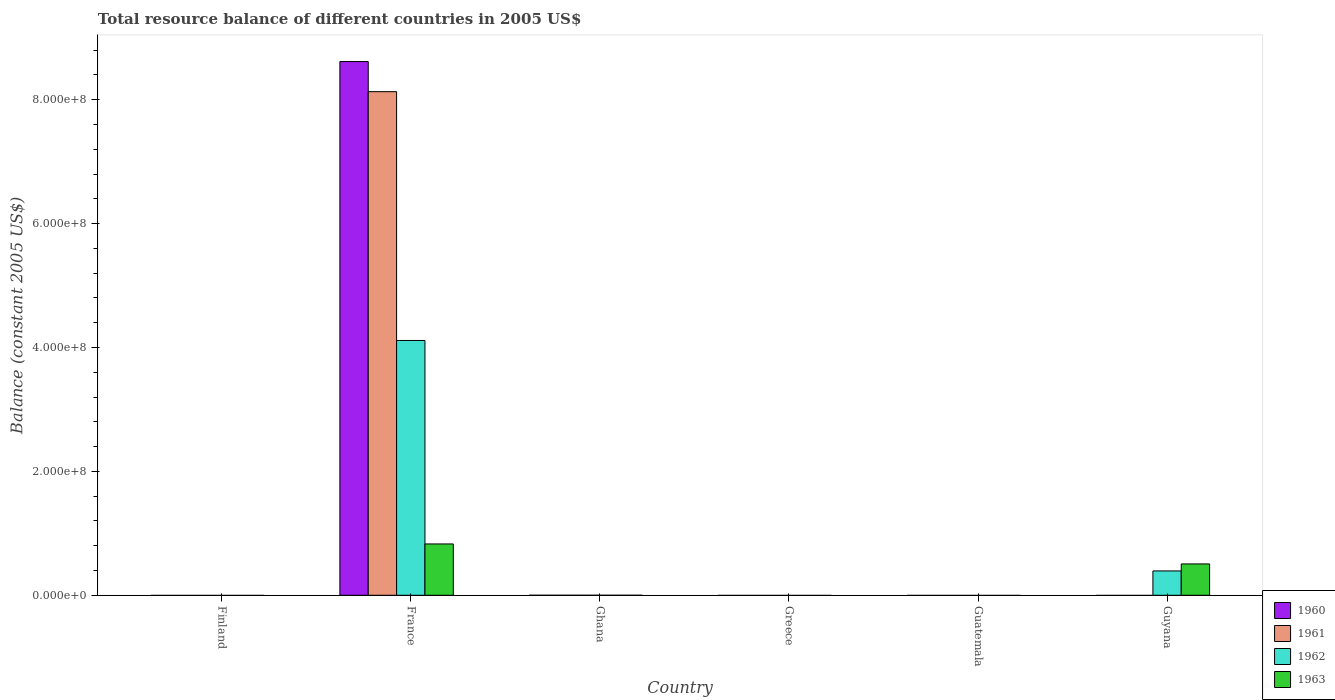How many bars are there on the 4th tick from the left?
Keep it short and to the point. 0. In how many cases, is the number of bars for a given country not equal to the number of legend labels?
Your answer should be very brief. 5. What is the total resource balance in 1961 in Guatemala?
Your answer should be very brief. 0. Across all countries, what is the maximum total resource balance in 1960?
Give a very brief answer. 8.62e+08. In which country was the total resource balance in 1963 maximum?
Give a very brief answer. France. What is the total total resource balance in 1960 in the graph?
Make the answer very short. 8.62e+08. What is the difference between the total resource balance in 1963 in France and the total resource balance in 1961 in Finland?
Offer a terse response. 8.29e+07. What is the average total resource balance in 1960 per country?
Make the answer very short. 1.44e+08. What is the difference between the total resource balance of/in 1963 and total resource balance of/in 1962 in France?
Give a very brief answer. -3.28e+08. What is the difference between the highest and the lowest total resource balance in 1963?
Provide a short and direct response. 8.29e+07. Is it the case that in every country, the sum of the total resource balance in 1960 and total resource balance in 1962 is greater than the sum of total resource balance in 1963 and total resource balance in 1961?
Provide a short and direct response. No. Is it the case that in every country, the sum of the total resource balance in 1963 and total resource balance in 1962 is greater than the total resource balance in 1960?
Ensure brevity in your answer.  No. How many bars are there?
Ensure brevity in your answer.  6. Are all the bars in the graph horizontal?
Provide a succinct answer. No. How many countries are there in the graph?
Your answer should be compact. 6. What is the difference between two consecutive major ticks on the Y-axis?
Your answer should be compact. 2.00e+08. Are the values on the major ticks of Y-axis written in scientific E-notation?
Make the answer very short. Yes. Does the graph contain any zero values?
Make the answer very short. Yes. How are the legend labels stacked?
Make the answer very short. Vertical. What is the title of the graph?
Keep it short and to the point. Total resource balance of different countries in 2005 US$. Does "2010" appear as one of the legend labels in the graph?
Offer a terse response. No. What is the label or title of the Y-axis?
Offer a very short reply. Balance (constant 2005 US$). What is the Balance (constant 2005 US$) of 1960 in Finland?
Make the answer very short. 0. What is the Balance (constant 2005 US$) in 1963 in Finland?
Your answer should be very brief. 0. What is the Balance (constant 2005 US$) of 1960 in France?
Your answer should be very brief. 8.62e+08. What is the Balance (constant 2005 US$) of 1961 in France?
Keep it short and to the point. 8.13e+08. What is the Balance (constant 2005 US$) of 1962 in France?
Offer a very short reply. 4.11e+08. What is the Balance (constant 2005 US$) of 1963 in France?
Offer a very short reply. 8.29e+07. What is the Balance (constant 2005 US$) in 1960 in Ghana?
Keep it short and to the point. 0. What is the Balance (constant 2005 US$) in 1961 in Ghana?
Provide a short and direct response. 0. What is the Balance (constant 2005 US$) of 1962 in Ghana?
Keep it short and to the point. 0. What is the Balance (constant 2005 US$) in 1960 in Greece?
Provide a short and direct response. 0. What is the Balance (constant 2005 US$) of 1961 in Greece?
Make the answer very short. 0. What is the Balance (constant 2005 US$) of 1960 in Guatemala?
Ensure brevity in your answer.  0. What is the Balance (constant 2005 US$) of 1961 in Guatemala?
Keep it short and to the point. 0. What is the Balance (constant 2005 US$) in 1962 in Guatemala?
Give a very brief answer. 0. What is the Balance (constant 2005 US$) of 1960 in Guyana?
Offer a very short reply. 0. What is the Balance (constant 2005 US$) of 1961 in Guyana?
Provide a succinct answer. 0. What is the Balance (constant 2005 US$) in 1962 in Guyana?
Ensure brevity in your answer.  3.93e+07. What is the Balance (constant 2005 US$) in 1963 in Guyana?
Make the answer very short. 5.06e+07. Across all countries, what is the maximum Balance (constant 2005 US$) of 1960?
Offer a very short reply. 8.62e+08. Across all countries, what is the maximum Balance (constant 2005 US$) in 1961?
Make the answer very short. 8.13e+08. Across all countries, what is the maximum Balance (constant 2005 US$) in 1962?
Your answer should be very brief. 4.11e+08. Across all countries, what is the maximum Balance (constant 2005 US$) of 1963?
Your answer should be compact. 8.29e+07. Across all countries, what is the minimum Balance (constant 2005 US$) in 1962?
Provide a succinct answer. 0. Across all countries, what is the minimum Balance (constant 2005 US$) of 1963?
Your answer should be very brief. 0. What is the total Balance (constant 2005 US$) of 1960 in the graph?
Provide a short and direct response. 8.62e+08. What is the total Balance (constant 2005 US$) in 1961 in the graph?
Your answer should be very brief. 8.13e+08. What is the total Balance (constant 2005 US$) in 1962 in the graph?
Keep it short and to the point. 4.51e+08. What is the total Balance (constant 2005 US$) of 1963 in the graph?
Keep it short and to the point. 1.33e+08. What is the difference between the Balance (constant 2005 US$) of 1962 in France and that in Guyana?
Provide a succinct answer. 3.72e+08. What is the difference between the Balance (constant 2005 US$) in 1963 in France and that in Guyana?
Offer a terse response. 3.23e+07. What is the difference between the Balance (constant 2005 US$) in 1960 in France and the Balance (constant 2005 US$) in 1962 in Guyana?
Your response must be concise. 8.22e+08. What is the difference between the Balance (constant 2005 US$) in 1960 in France and the Balance (constant 2005 US$) in 1963 in Guyana?
Your answer should be very brief. 8.11e+08. What is the difference between the Balance (constant 2005 US$) in 1961 in France and the Balance (constant 2005 US$) in 1962 in Guyana?
Offer a very short reply. 7.74e+08. What is the difference between the Balance (constant 2005 US$) of 1961 in France and the Balance (constant 2005 US$) of 1963 in Guyana?
Your answer should be compact. 7.62e+08. What is the difference between the Balance (constant 2005 US$) in 1962 in France and the Balance (constant 2005 US$) in 1963 in Guyana?
Provide a succinct answer. 3.61e+08. What is the average Balance (constant 2005 US$) in 1960 per country?
Provide a short and direct response. 1.44e+08. What is the average Balance (constant 2005 US$) in 1961 per country?
Your response must be concise. 1.35e+08. What is the average Balance (constant 2005 US$) of 1962 per country?
Make the answer very short. 7.51e+07. What is the average Balance (constant 2005 US$) of 1963 per country?
Ensure brevity in your answer.  2.22e+07. What is the difference between the Balance (constant 2005 US$) in 1960 and Balance (constant 2005 US$) in 1961 in France?
Your response must be concise. 4.86e+07. What is the difference between the Balance (constant 2005 US$) in 1960 and Balance (constant 2005 US$) in 1962 in France?
Provide a short and direct response. 4.50e+08. What is the difference between the Balance (constant 2005 US$) of 1960 and Balance (constant 2005 US$) of 1963 in France?
Your answer should be very brief. 7.79e+08. What is the difference between the Balance (constant 2005 US$) of 1961 and Balance (constant 2005 US$) of 1962 in France?
Provide a succinct answer. 4.02e+08. What is the difference between the Balance (constant 2005 US$) of 1961 and Balance (constant 2005 US$) of 1963 in France?
Provide a short and direct response. 7.30e+08. What is the difference between the Balance (constant 2005 US$) of 1962 and Balance (constant 2005 US$) of 1963 in France?
Your answer should be compact. 3.28e+08. What is the difference between the Balance (constant 2005 US$) of 1962 and Balance (constant 2005 US$) of 1963 in Guyana?
Offer a very short reply. -1.13e+07. What is the ratio of the Balance (constant 2005 US$) in 1962 in France to that in Guyana?
Provide a succinct answer. 10.47. What is the ratio of the Balance (constant 2005 US$) of 1963 in France to that in Guyana?
Your response must be concise. 1.64. What is the difference between the highest and the lowest Balance (constant 2005 US$) in 1960?
Give a very brief answer. 8.62e+08. What is the difference between the highest and the lowest Balance (constant 2005 US$) of 1961?
Keep it short and to the point. 8.13e+08. What is the difference between the highest and the lowest Balance (constant 2005 US$) in 1962?
Offer a very short reply. 4.11e+08. What is the difference between the highest and the lowest Balance (constant 2005 US$) of 1963?
Give a very brief answer. 8.29e+07. 